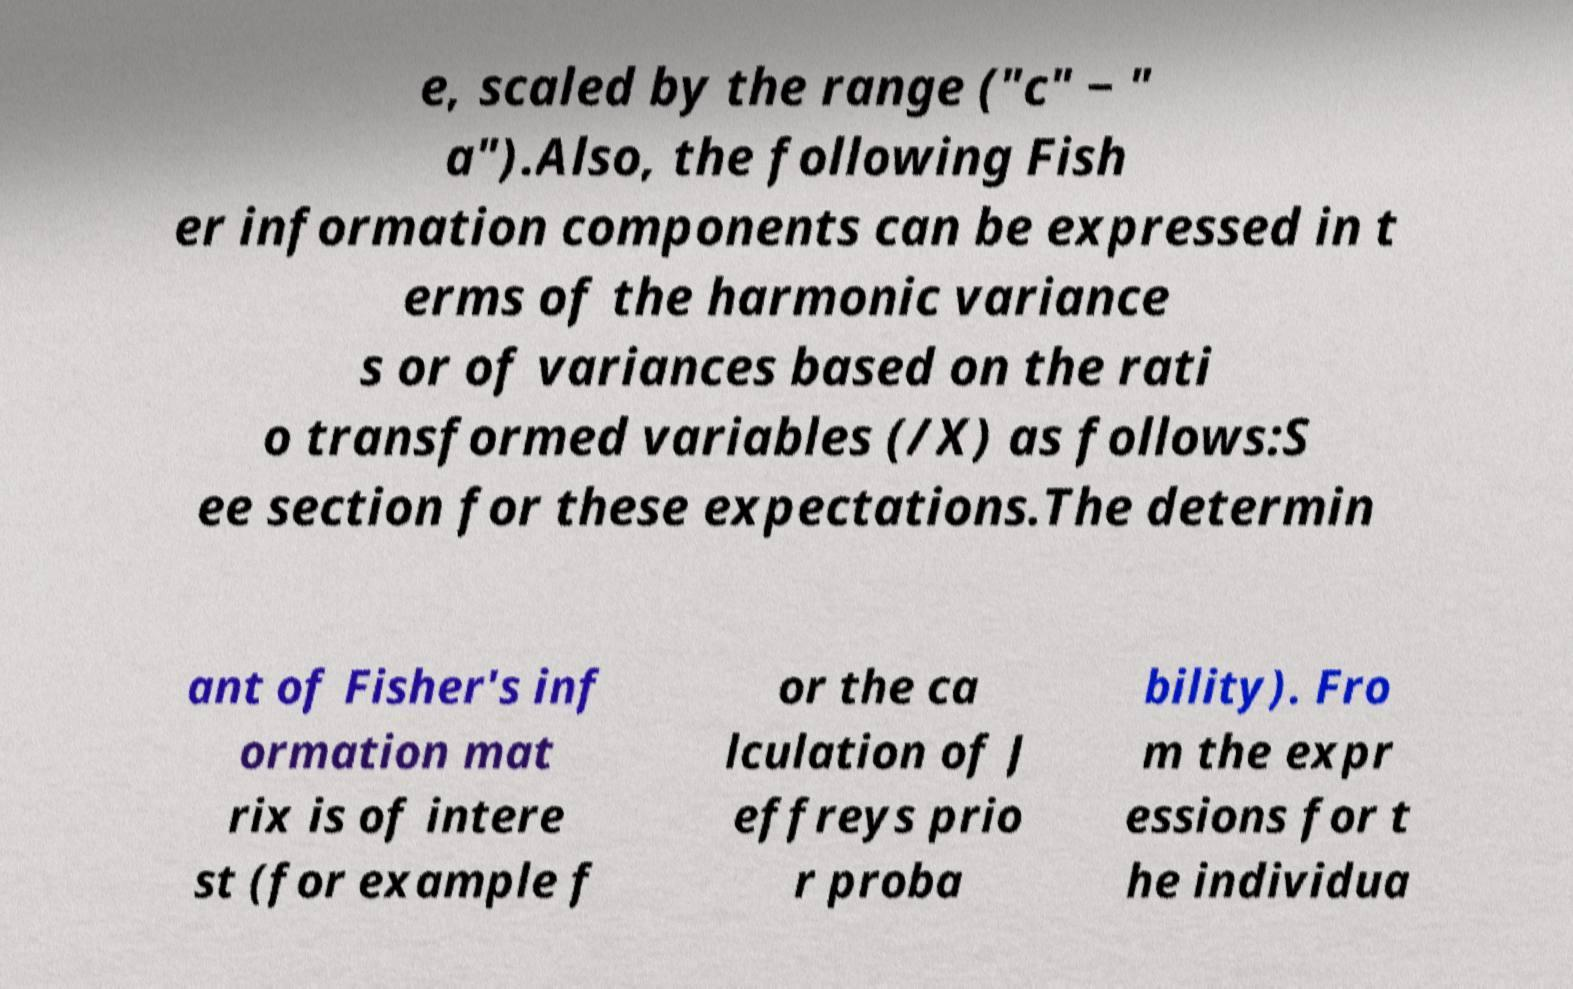For documentation purposes, I need the text within this image transcribed. Could you provide that? e, scaled by the range ("c" − " a").Also, the following Fish er information components can be expressed in t erms of the harmonic variance s or of variances based on the rati o transformed variables (/X) as follows:S ee section for these expectations.The determin ant of Fisher's inf ormation mat rix is of intere st (for example f or the ca lculation of J effreys prio r proba bility). Fro m the expr essions for t he individua 